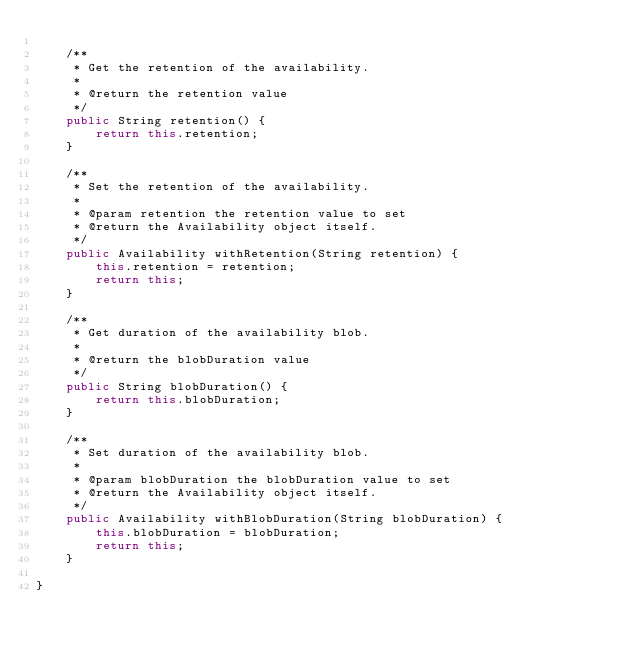Convert code to text. <code><loc_0><loc_0><loc_500><loc_500><_Java_>
    /**
     * Get the retention of the availability.
     *
     * @return the retention value
     */
    public String retention() {
        return this.retention;
    }

    /**
     * Set the retention of the availability.
     *
     * @param retention the retention value to set
     * @return the Availability object itself.
     */
    public Availability withRetention(String retention) {
        this.retention = retention;
        return this;
    }

    /**
     * Get duration of the availability blob.
     *
     * @return the blobDuration value
     */
    public String blobDuration() {
        return this.blobDuration;
    }

    /**
     * Set duration of the availability blob.
     *
     * @param blobDuration the blobDuration value to set
     * @return the Availability object itself.
     */
    public Availability withBlobDuration(String blobDuration) {
        this.blobDuration = blobDuration;
        return this;
    }

}
</code> 